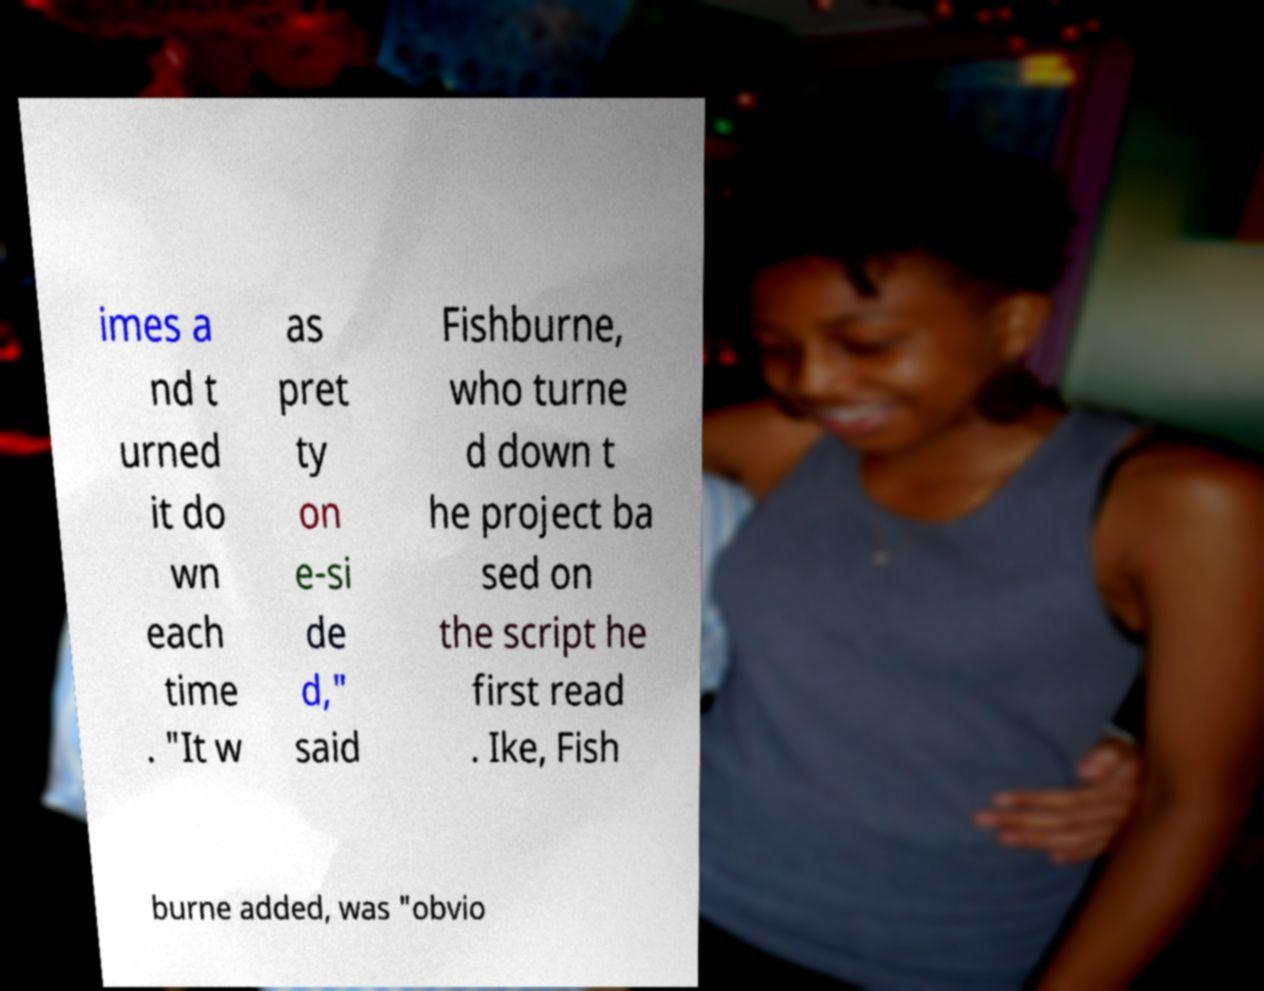Please identify and transcribe the text found in this image. imes a nd t urned it do wn each time . "It w as pret ty on e-si de d," said Fishburne, who turne d down t he project ba sed on the script he first read . Ike, Fish burne added, was "obvio 